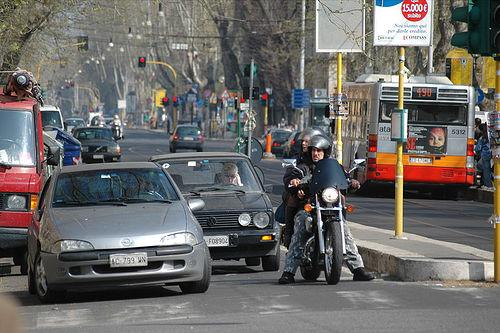Why are all the vehicles on the left not moving? Please explain your reasoning. red light. The vehicles are at a red light. 